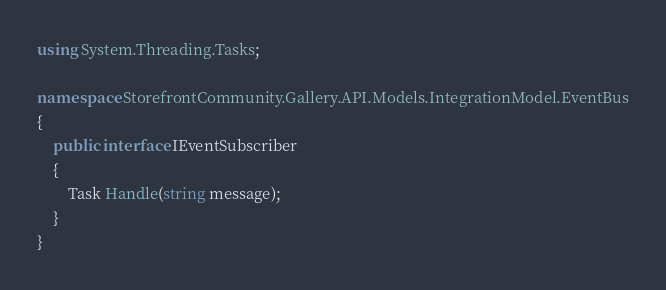Convert code to text. <code><loc_0><loc_0><loc_500><loc_500><_C#_>using System.Threading.Tasks;

namespace StorefrontCommunity.Gallery.API.Models.IntegrationModel.EventBus
{
    public interface IEventSubscriber
    {
        Task Handle(string message);
    }
}
</code> 